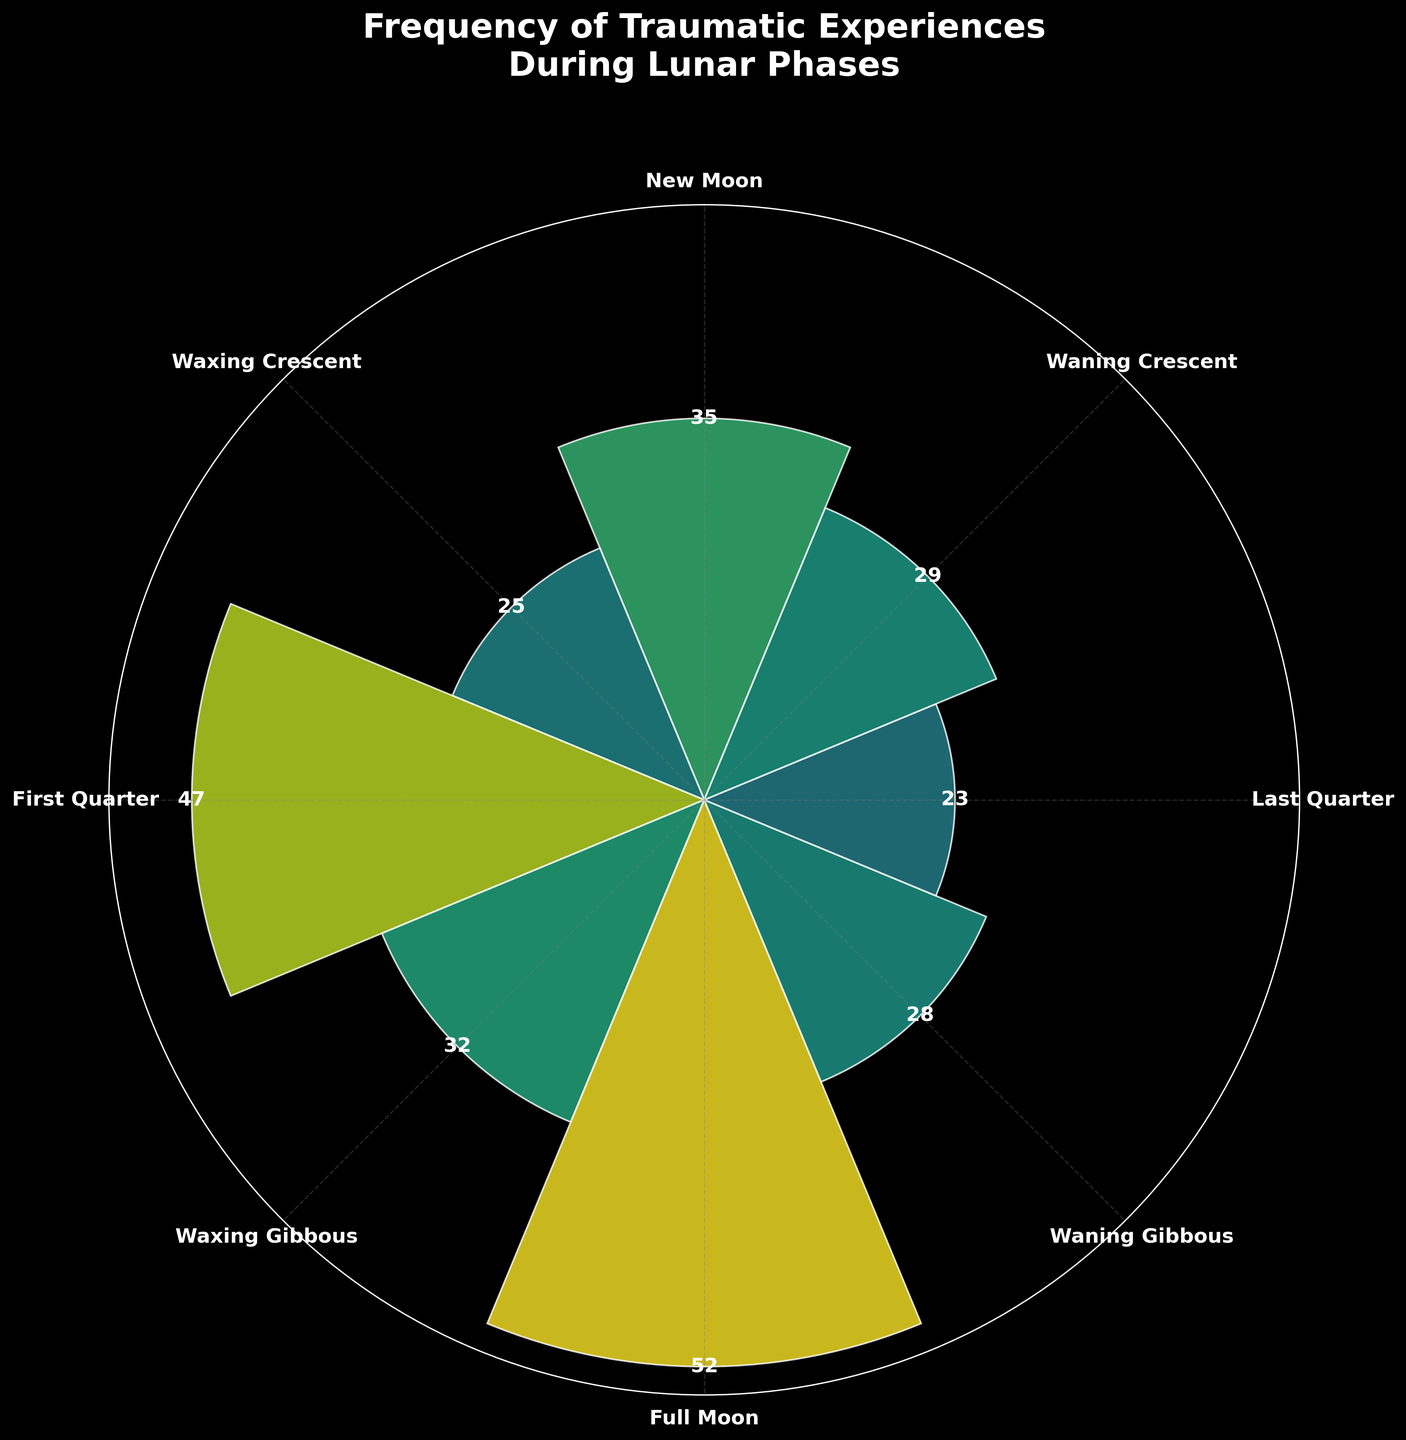What is the title of the figure? The title is located at the top of the chart and usually gives a brief description of what the figure represents. The title of the chart is "Frequency of Traumatic Experiences During Lunar Phases".
Answer: Frequency of Traumatic Experiences During Lunar Phases Which lunar phase has the highest frequency of traumatic experiences? To determine the highest frequency, look at the bars in the chart and identify the one that extends the furthest from the center. The Full Moon phase has the highest frequency, with a value of 52.
Answer: Full Moon How many lunar phases have a frequency of traumatic experiences above 30? To answer this, count the number of bars that extend beyond the 30-mark radius. The lunar phases with frequencies above 30 are New Moon, First Quarter, Waxing Gibbous, Full Moon, and Waning Gibbous, totaling 5 lunar phases.
Answer: 5 What's the difference in frequency of traumatic experiences between the Full Moon and Last Quarter phases? Locate the bars for the Full Moon and Last Quarter phases. The Full Moon has a frequency of 52, while the Last Quarter has 23. Subtract 23 from 52 to find the difference: 52 - 23 = 29.
Answer: 29 Which lunar phase has the least frequency of traumatic experiences? Identify the bar that is shortest, indicating the smallest frequency. The Last Quarter phase has the least frequency, with a value of 23.
Answer: Last Quarter How many lunar phases have frequencies between 25 and 35? Count the number of bars where the frequencies fall within the 25 to 35 range. The lunar phases Waxing Crescent, Waxing Gibbous, Waning Gibbous, and Waning Crescent have frequencies within this range, totaling 4.
Answer: 4 Compare the frequency of traumatic experiences during the New Moon and Waxing Crescent phases. Which is higher? Find the bars corresponding to New Moon and Waxing Crescent phases. The New Moon has a frequency of 35, and the Waxing Crescent has 25. Since 35 is greater than 25, the New Moon has a higher frequency.
Answer: New Moon What is the average frequency of traumatic experiences across all lunar phases? To calculate the average, sum all the frequencies and divide by the number of phases. The frequencies are 35, 25, 47, 32, 52, 28, 23, 29. Sum them up: 35 + 25 + 47 + 32 + 52 + 28 + 23 + 29 = 271. There are 8 phases, so the average is 271 / 8 = 33.875.
Answer: 33.875 What are the colors used to represent high and low frequencies of traumatic experiences? Examine the color gradient used in the chart. Higher frequencies are represented by a lighter color, while lower frequencies are represented by a darker color.
Answer: Lighter for high frequencies, darker for low frequencies 